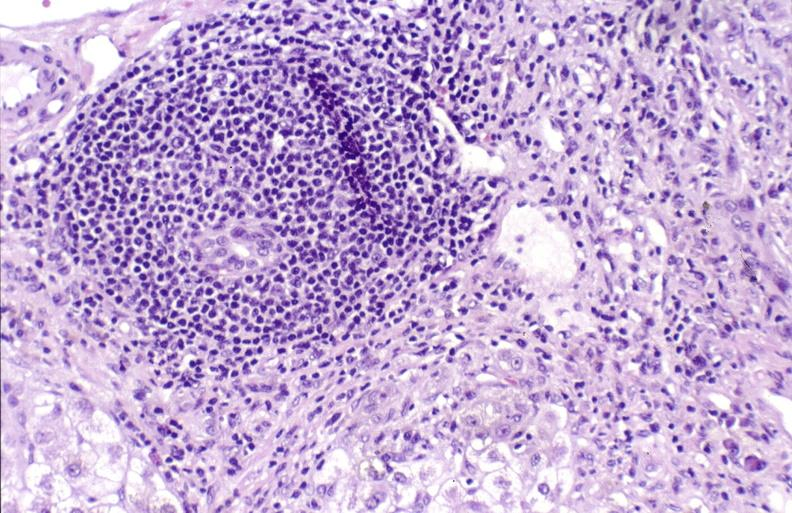what is present?
Answer the question using a single word or phrase. Hepatobiliary 